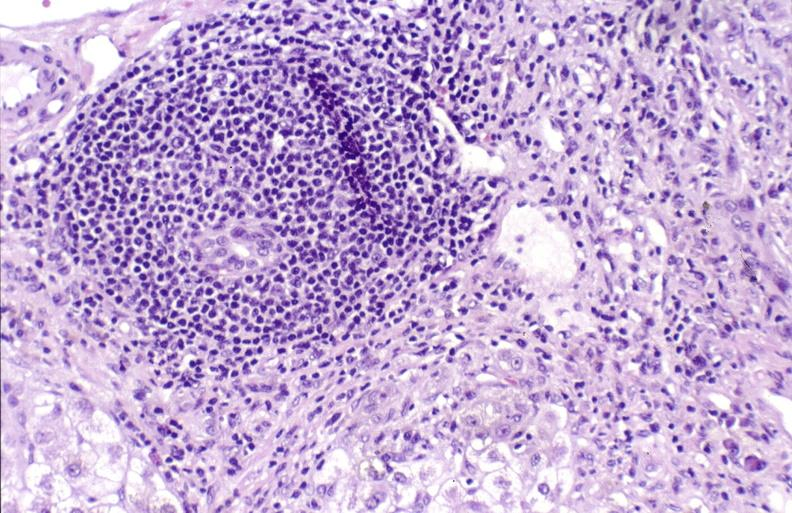what is present?
Answer the question using a single word or phrase. Hepatobiliary 